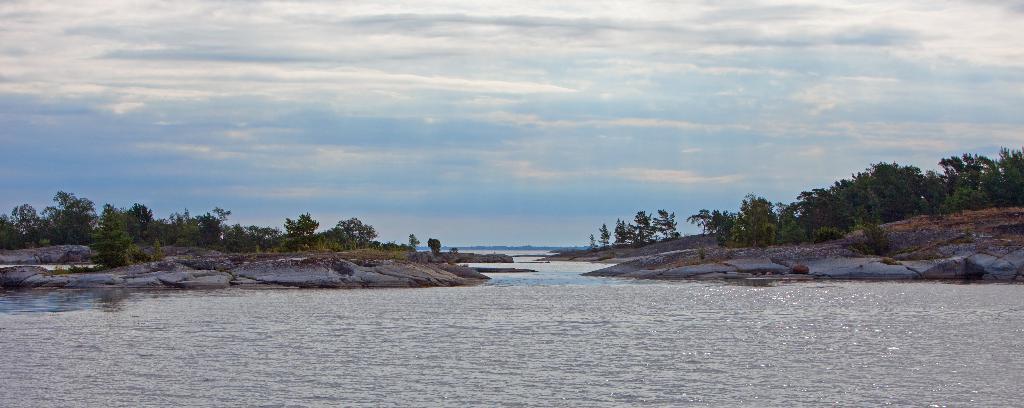Describe this image in one or two sentences. In this image I can see water. There are rocks and trees on the either sides. There is sky at the top. 